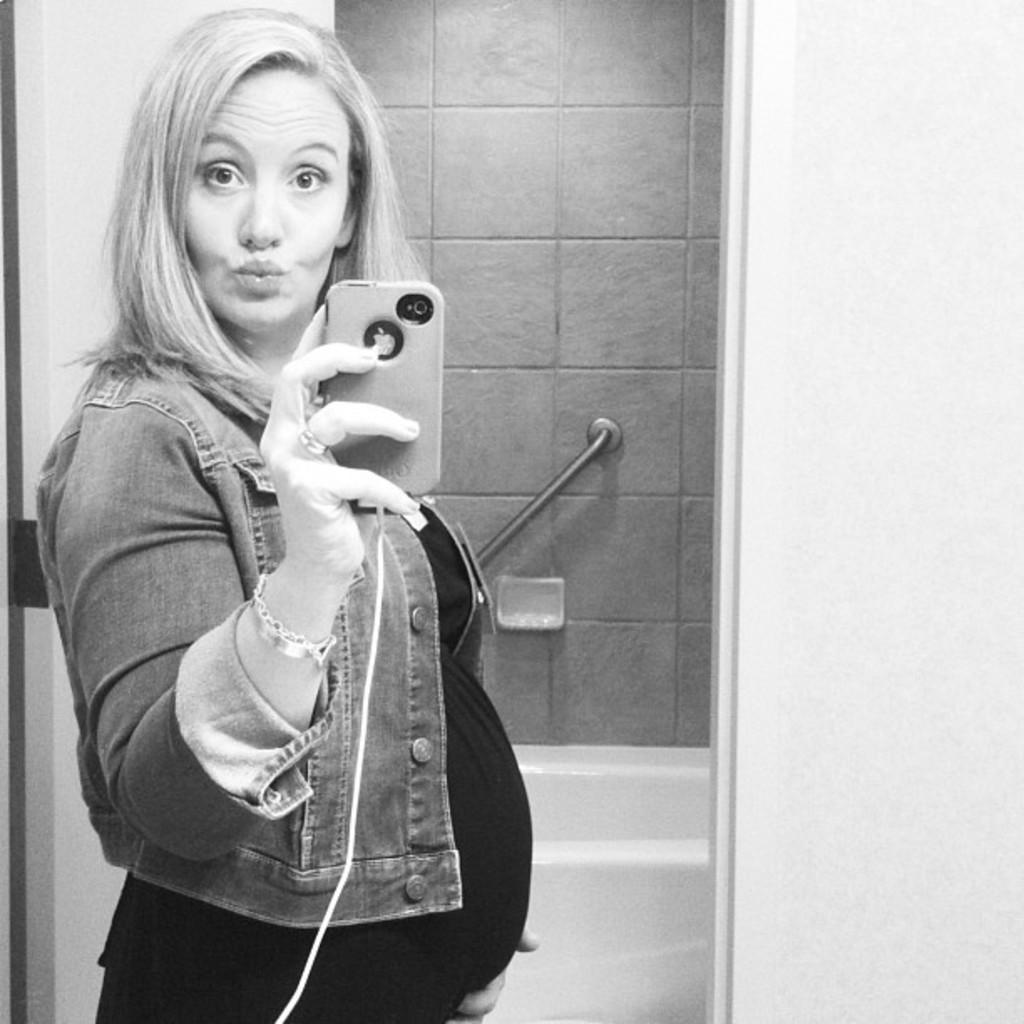How would you summarize this image in a sentence or two? This picture shows a woman standing and holding a mobile in her hand and we see a bathtub and a handle to hold and we see a door. 